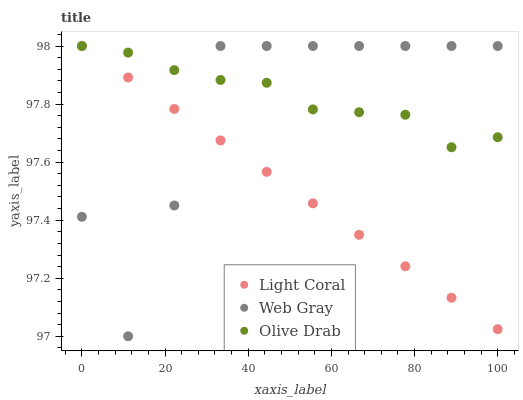Does Light Coral have the minimum area under the curve?
Answer yes or no. Yes. Does Olive Drab have the maximum area under the curve?
Answer yes or no. Yes. Does Web Gray have the minimum area under the curve?
Answer yes or no. No. Does Web Gray have the maximum area under the curve?
Answer yes or no. No. Is Light Coral the smoothest?
Answer yes or no. Yes. Is Web Gray the roughest?
Answer yes or no. Yes. Is Olive Drab the smoothest?
Answer yes or no. No. Is Olive Drab the roughest?
Answer yes or no. No. Does Web Gray have the lowest value?
Answer yes or no. Yes. Does Olive Drab have the lowest value?
Answer yes or no. No. Does Olive Drab have the highest value?
Answer yes or no. Yes. Does Light Coral intersect Web Gray?
Answer yes or no. Yes. Is Light Coral less than Web Gray?
Answer yes or no. No. Is Light Coral greater than Web Gray?
Answer yes or no. No. 